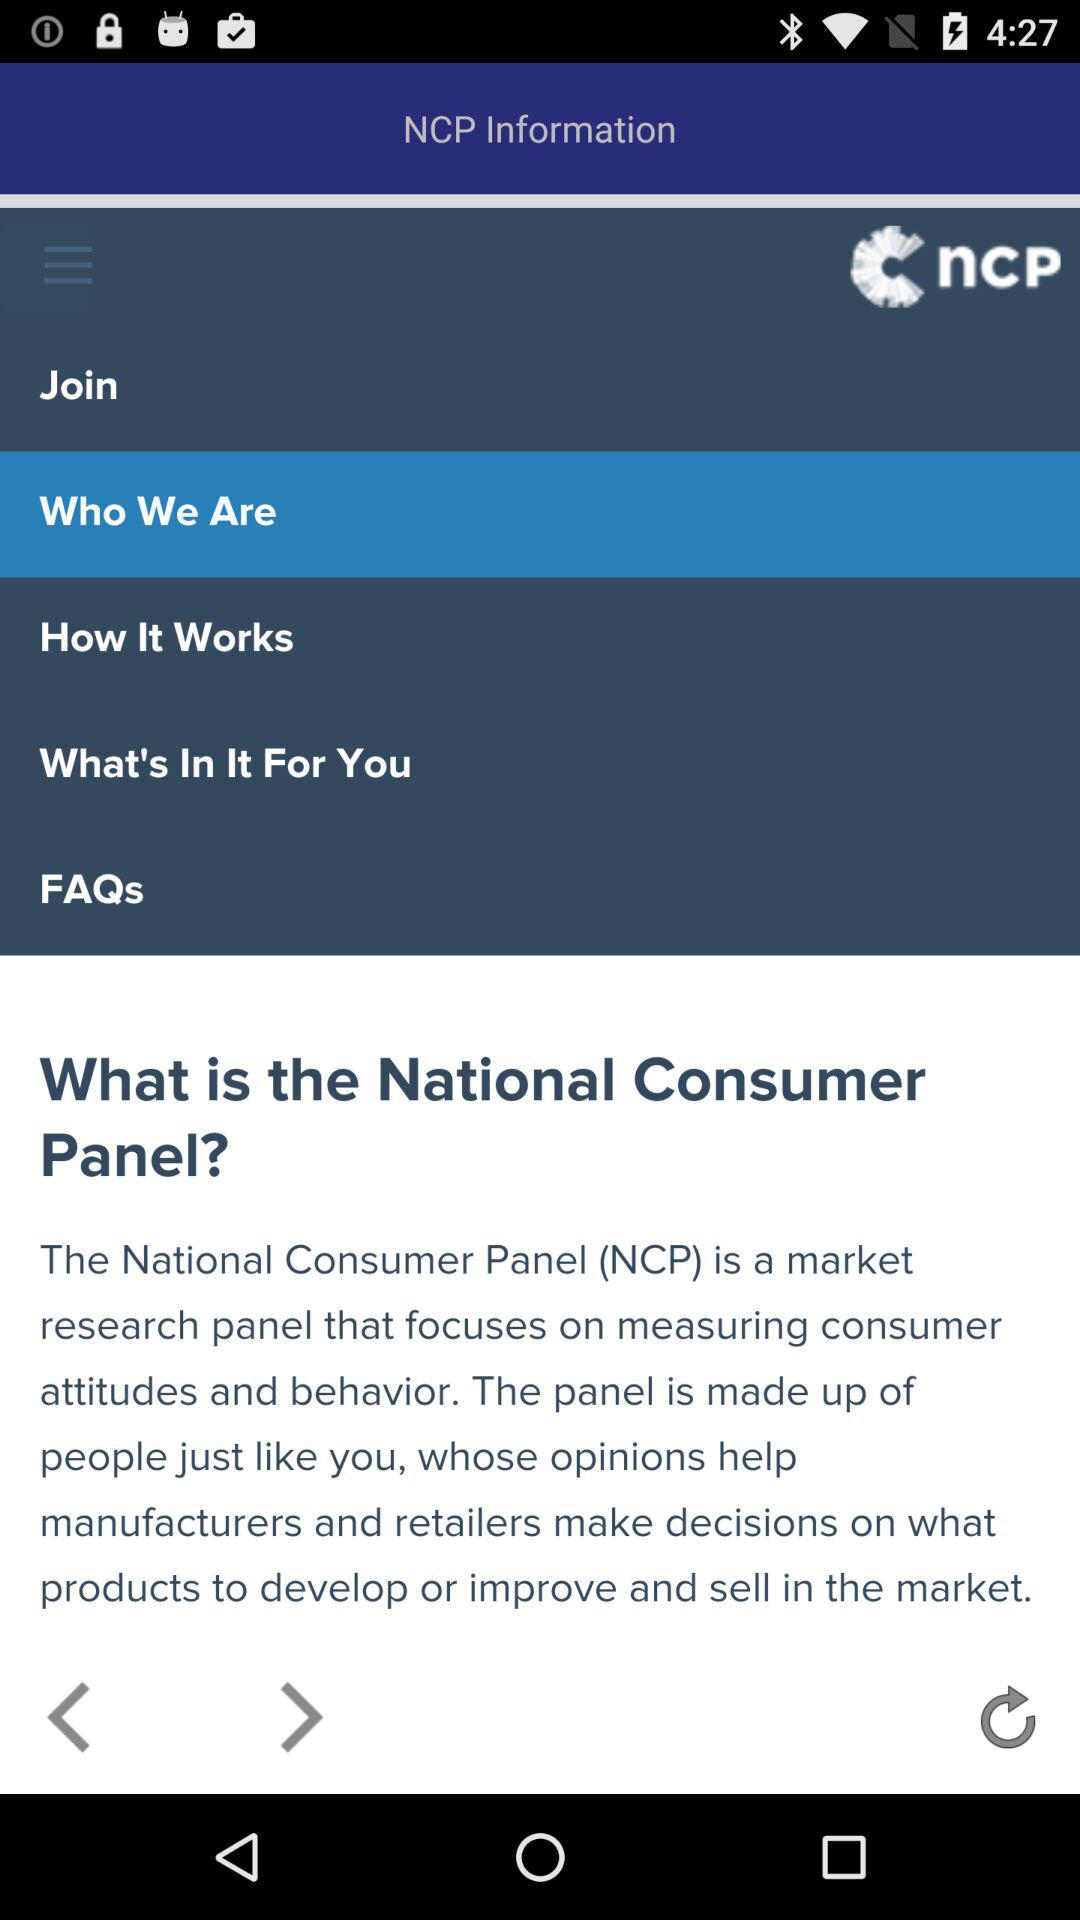Which item is selected in the menu? The selected item in the menu is "Who We Are". 